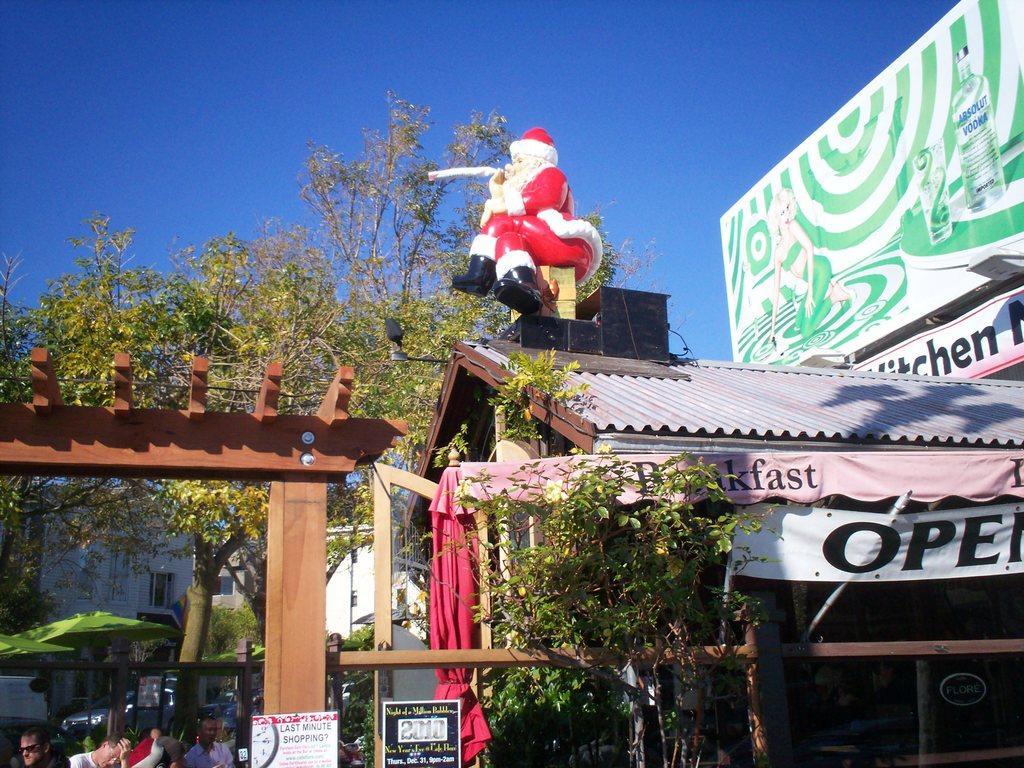Please provide a concise description of this image. In this image we can see a store. There is a arch. There are people at the bottom of the image. There are trees in the background of the image. At the top of the image there is sky. 